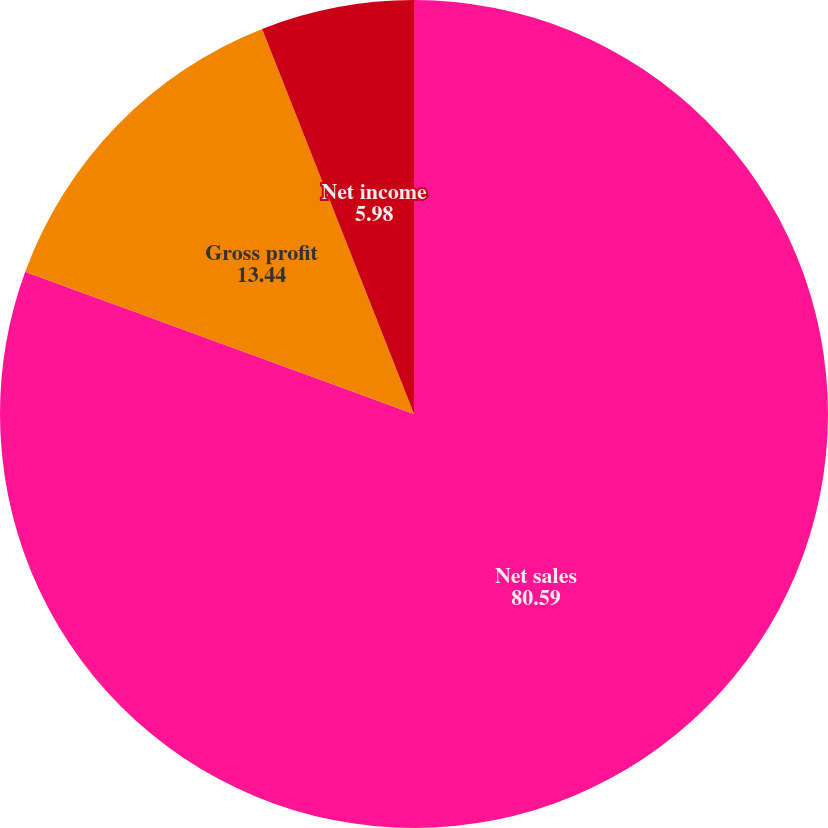Convert chart to OTSL. <chart><loc_0><loc_0><loc_500><loc_500><pie_chart><fcel>Net sales<fcel>Gross profit<fcel>Net income<nl><fcel>80.59%<fcel>13.44%<fcel>5.98%<nl></chart> 